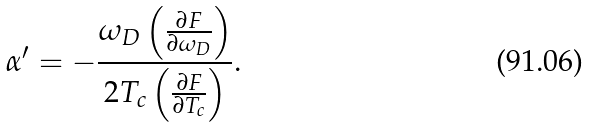Convert formula to latex. <formula><loc_0><loc_0><loc_500><loc_500>\alpha ^ { \prime } = - \frac { \omega _ { D } \left ( \frac { \partial F } { \partial \omega _ { D } } \right ) } { 2 T _ { c } \left ( \frac { \partial F } { \partial T _ { c } } \right ) } .</formula> 